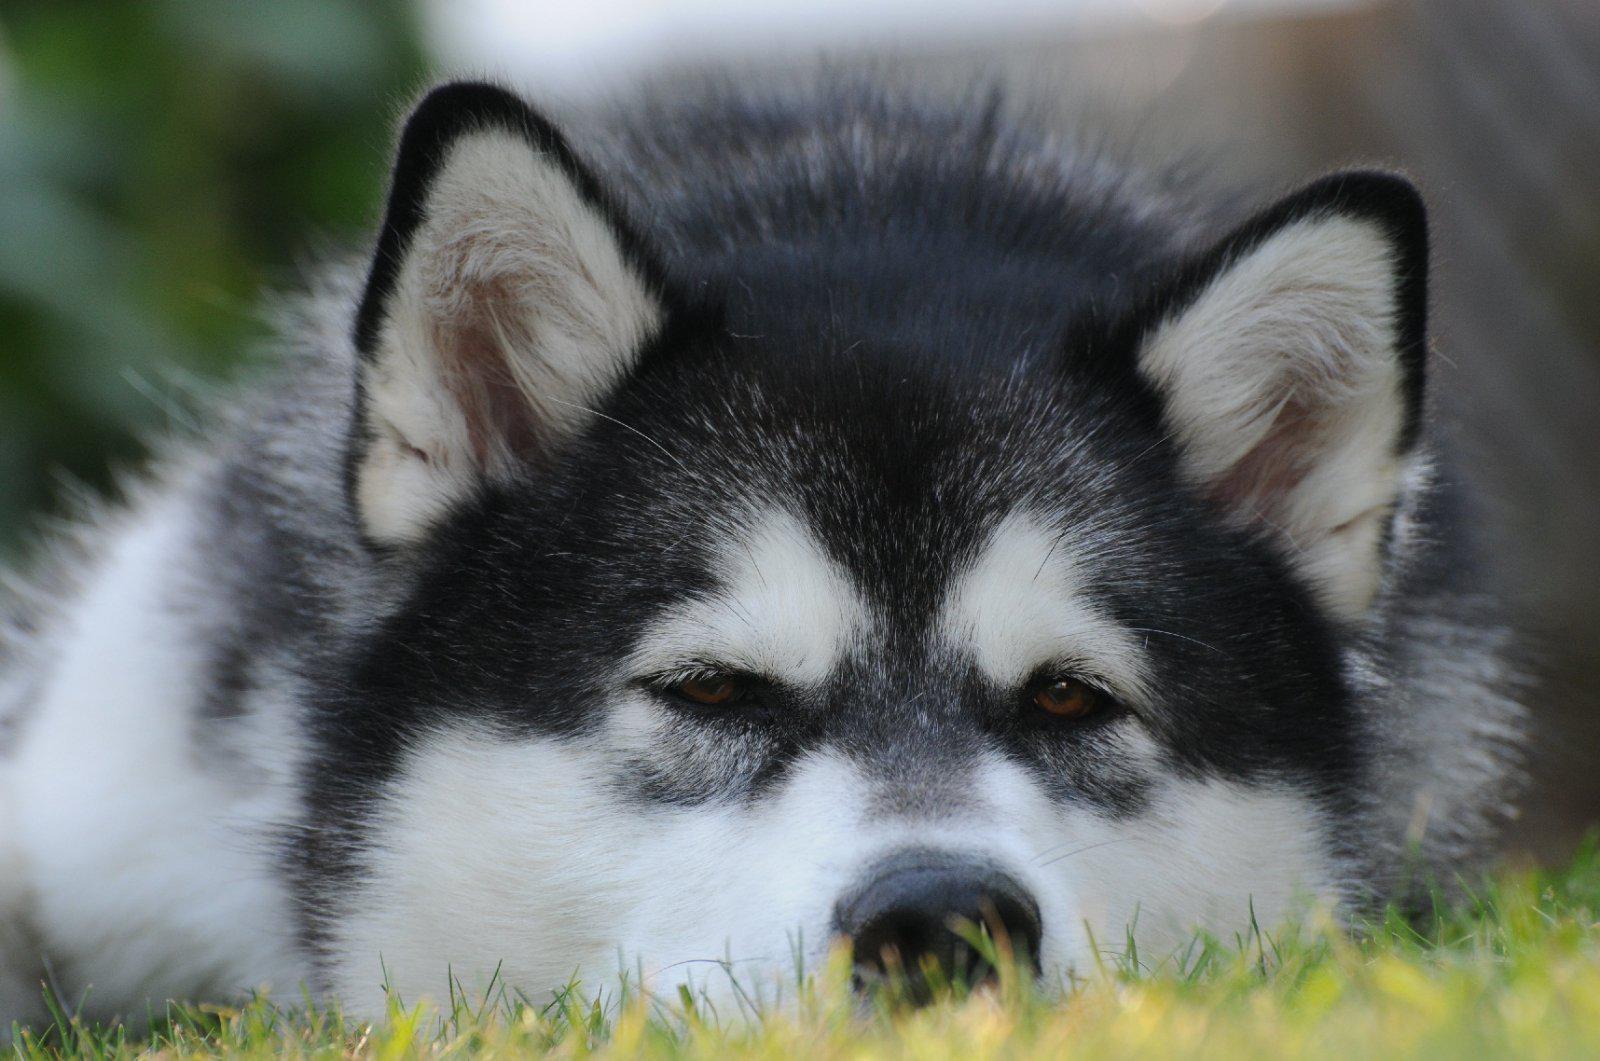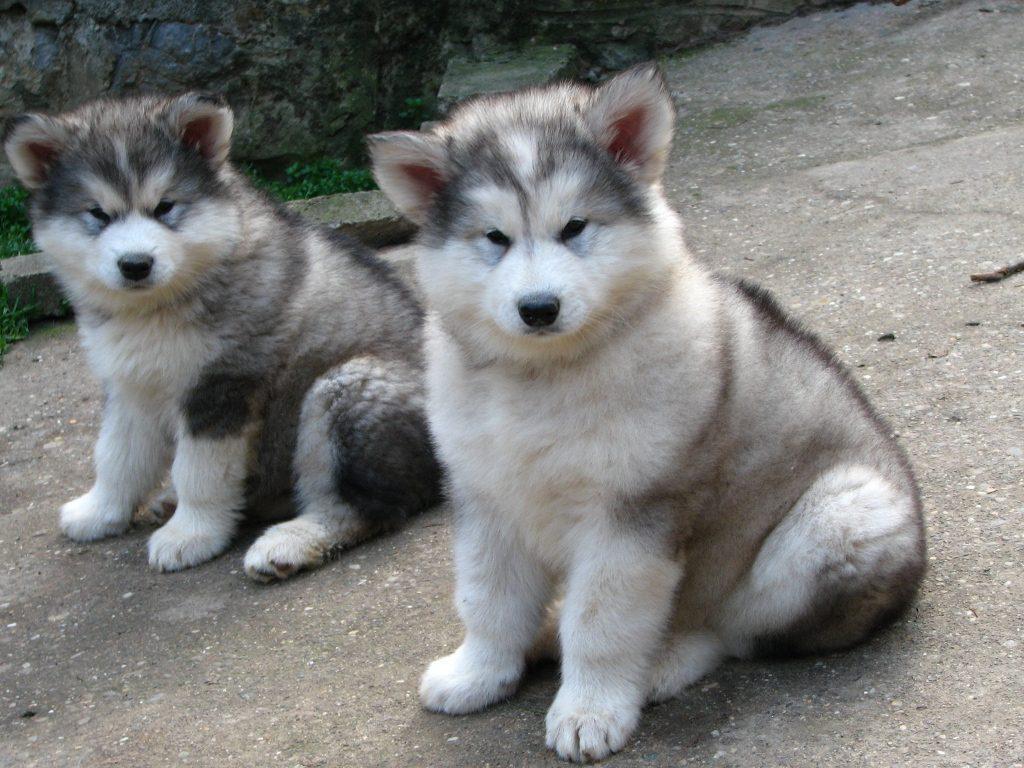The first image is the image on the left, the second image is the image on the right. For the images shown, is this caption "Each image contains one adult husky, and one of the dogs pictured stands on all fours with its mouth open and tongue hanging out." true? Answer yes or no. No. The first image is the image on the left, the second image is the image on the right. Given the left and right images, does the statement "The dog in the image on the left is standing in the grass." hold true? Answer yes or no. No. 